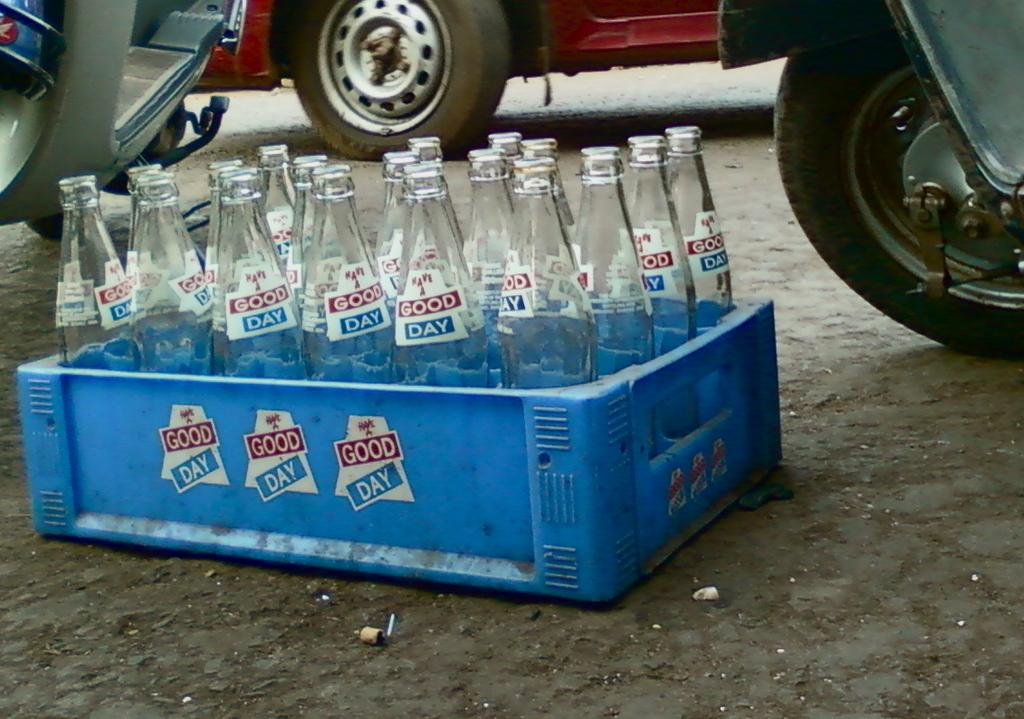What is the main object in the image? There is a tray in the image. What is on the tray? The tray contains a number of bottles. What can be seen in the background of the image? There is a wheel of a vehicle and other vehicles visible in the background of the image. How many beds are visible in the image? There are no beds present in the image. Is the quill used for writing in the image? There is no quill present in the image. 